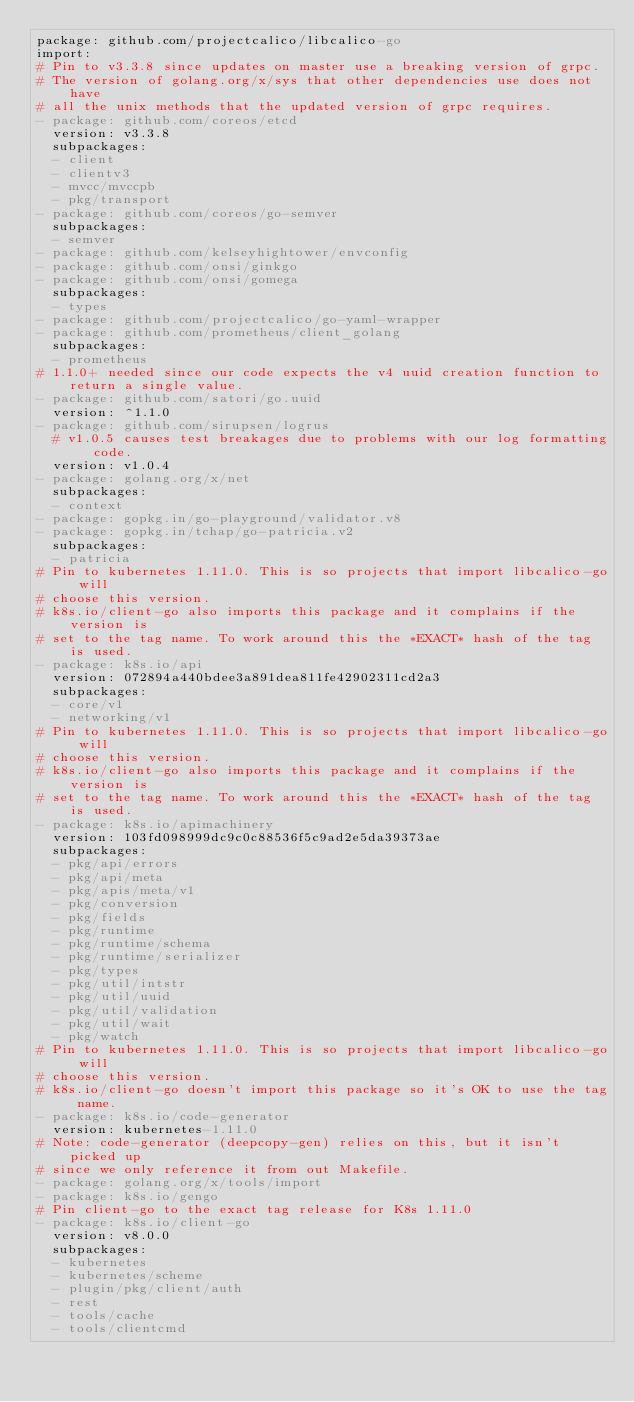<code> <loc_0><loc_0><loc_500><loc_500><_YAML_>package: github.com/projectcalico/libcalico-go
import:
# Pin to v3.3.8 since updates on master use a breaking version of grpc.
# The version of golang.org/x/sys that other dependencies use does not have
# all the unix methods that the updated version of grpc requires.
- package: github.com/coreos/etcd
  version: v3.3.8
  subpackages:
  - client
  - clientv3
  - mvcc/mvccpb
  - pkg/transport
- package: github.com/coreos/go-semver
  subpackages:
  - semver
- package: github.com/kelseyhightower/envconfig
- package: github.com/onsi/ginkgo
- package: github.com/onsi/gomega
  subpackages:
  - types
- package: github.com/projectcalico/go-yaml-wrapper
- package: github.com/prometheus/client_golang
  subpackages:
  - prometheus
# 1.1.0+ needed since our code expects the v4 uuid creation function to return a single value.
- package: github.com/satori/go.uuid
  version: ^1.1.0
- package: github.com/sirupsen/logrus
  # v1.0.5 causes test breakages due to problems with our log formatting code.
  version: v1.0.4
- package: golang.org/x/net
  subpackages:
  - context
- package: gopkg.in/go-playground/validator.v8
- package: gopkg.in/tchap/go-patricia.v2
  subpackages:
  - patricia
# Pin to kubernetes 1.11.0. This is so projects that import libcalico-go will
# choose this version.
# k8s.io/client-go also imports this package and it complains if the version is 
# set to the tag name. To work around this the *EXACT* hash of the tag is used.
- package: k8s.io/api
  version: 072894a440bdee3a891dea811fe42902311cd2a3
  subpackages:
  - core/v1
  - networking/v1
# Pin to kubernetes 1.11.0. This is so projects that import libcalico-go will
# choose this version.
# k8s.io/client-go also imports this package and it complains if the version is 
# set to the tag name. To work around this the *EXACT* hash of the tag is used.
- package: k8s.io/apimachinery
  version: 103fd098999dc9c0c88536f5c9ad2e5da39373ae
  subpackages:
  - pkg/api/errors
  - pkg/api/meta
  - pkg/apis/meta/v1
  - pkg/conversion
  - pkg/fields
  - pkg/runtime
  - pkg/runtime/schema
  - pkg/runtime/serializer
  - pkg/types
  - pkg/util/intstr
  - pkg/util/uuid
  - pkg/util/validation
  - pkg/util/wait
  - pkg/watch
# Pin to kubernetes 1.11.0. This is so projects that import libcalico-go will
# choose this version.
# k8s.io/client-go doesn't import this package so it's OK to use the tag name.
- package: k8s.io/code-generator
  version: kubernetes-1.11.0
# Note: code-generator (deepcopy-gen) relies on this, but it isn't picked up
# since we only reference it from out Makefile.
- package: golang.org/x/tools/import
- package: k8s.io/gengo
# Pin client-go to the exact tag release for K8s 1.11.0
- package: k8s.io/client-go
  version: v8.0.0
  subpackages:
  - kubernetes
  - kubernetes/scheme
  - plugin/pkg/client/auth
  - rest
  - tools/cache
  - tools/clientcmd
</code> 